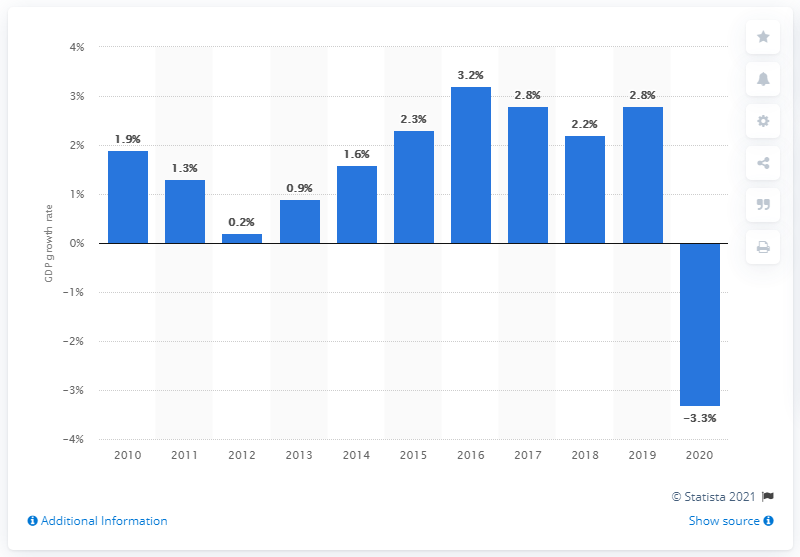Highlight a few significant elements in this photo. The highest GDP growth rate measured in 2019 was 2.8%. 